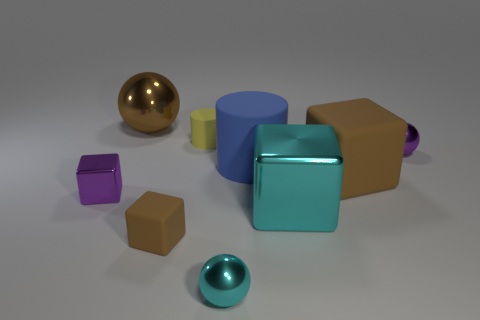Subtract all cyan cubes. How many cubes are left? 3 Subtract all cyan metal balls. How many balls are left? 2 Subtract all cubes. How many objects are left? 5 Subtract all yellow balls. How many green cylinders are left? 0 Add 9 tiny purple metal balls. How many tiny purple metal balls are left? 10 Add 5 small purple shiny cubes. How many small purple shiny cubes exist? 6 Subtract 0 cyan cylinders. How many objects are left? 9 Subtract 2 cylinders. How many cylinders are left? 0 Subtract all brown cylinders. Subtract all red cubes. How many cylinders are left? 2 Subtract all small cyan things. Subtract all cyan metallic balls. How many objects are left? 7 